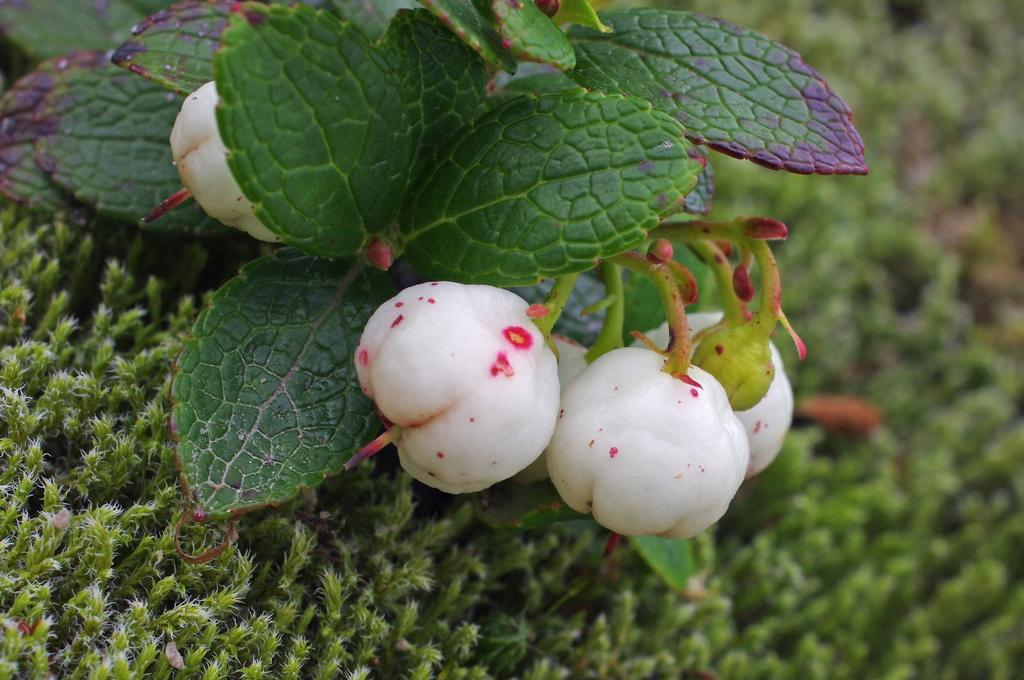What type of fruit is present in the image? There are bilberries in the image. What else can be seen in the image besides the bilberries? There are leaves and small plants on the floor in the image. How does the celery taste in the image? There is no celery present in the image, so it cannot be tasted or described. 